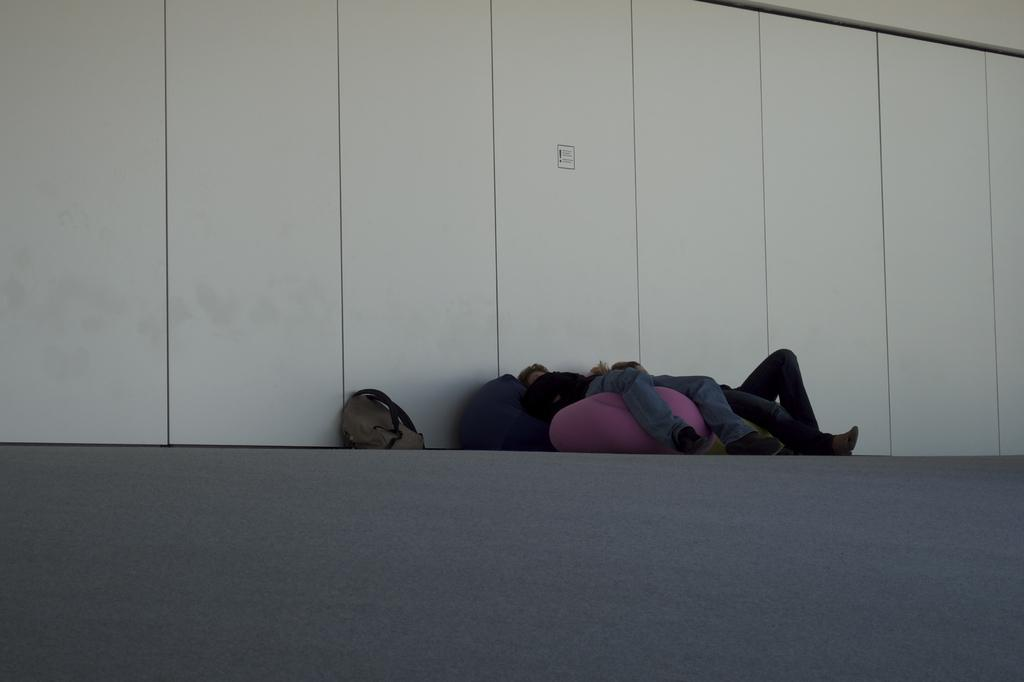What object can be seen in the image? There is a bag in the image. What are the people in the foreground of the image doing? The people are laying in the foreground of the image. What can be seen in the background of the image? There is a wall in the background of the image. How many fans are visible in the image? There are no fans present in the image. What type of ice can be seen melting on the people in the image? There is no ice present in the image, and the people are laying down, not melting. 